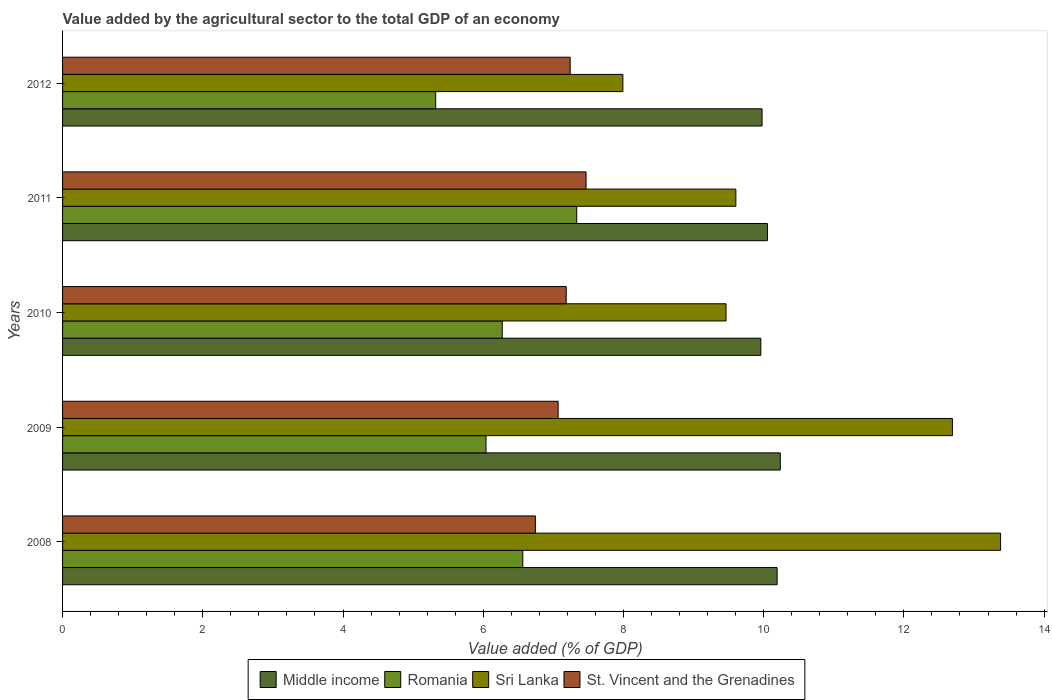How many different coloured bars are there?
Provide a succinct answer. 4. How many groups of bars are there?
Offer a very short reply. 5. Are the number of bars per tick equal to the number of legend labels?
Keep it short and to the point. Yes. How many bars are there on the 1st tick from the top?
Offer a terse response. 4. How many bars are there on the 1st tick from the bottom?
Offer a terse response. 4. What is the label of the 5th group of bars from the top?
Ensure brevity in your answer.  2008. What is the value added by the agricultural sector to the total GDP in Sri Lanka in 2010?
Make the answer very short. 9.46. Across all years, what is the maximum value added by the agricultural sector to the total GDP in Middle income?
Your response must be concise. 10.24. Across all years, what is the minimum value added by the agricultural sector to the total GDP in Sri Lanka?
Keep it short and to the point. 7.99. In which year was the value added by the agricultural sector to the total GDP in Middle income maximum?
Give a very brief answer. 2009. In which year was the value added by the agricultural sector to the total GDP in St. Vincent and the Grenadines minimum?
Give a very brief answer. 2008. What is the total value added by the agricultural sector to the total GDP in Romania in the graph?
Offer a very short reply. 31.53. What is the difference between the value added by the agricultural sector to the total GDP in Middle income in 2008 and that in 2009?
Offer a very short reply. -0.05. What is the difference between the value added by the agricultural sector to the total GDP in Romania in 2010 and the value added by the agricultural sector to the total GDP in Sri Lanka in 2008?
Your answer should be very brief. -7.11. What is the average value added by the agricultural sector to the total GDP in Romania per year?
Provide a short and direct response. 6.31. In the year 2009, what is the difference between the value added by the agricultural sector to the total GDP in Romania and value added by the agricultural sector to the total GDP in St. Vincent and the Grenadines?
Offer a terse response. -1.03. In how many years, is the value added by the agricultural sector to the total GDP in St. Vincent and the Grenadines greater than 13.2 %?
Your answer should be very brief. 0. What is the ratio of the value added by the agricultural sector to the total GDP in St. Vincent and the Grenadines in 2008 to that in 2010?
Ensure brevity in your answer.  0.94. Is the difference between the value added by the agricultural sector to the total GDP in Romania in 2011 and 2012 greater than the difference between the value added by the agricultural sector to the total GDP in St. Vincent and the Grenadines in 2011 and 2012?
Your answer should be very brief. Yes. What is the difference between the highest and the second highest value added by the agricultural sector to the total GDP in Sri Lanka?
Provide a succinct answer. 0.69. What is the difference between the highest and the lowest value added by the agricultural sector to the total GDP in Sri Lanka?
Your response must be concise. 5.39. In how many years, is the value added by the agricultural sector to the total GDP in Romania greater than the average value added by the agricultural sector to the total GDP in Romania taken over all years?
Your answer should be compact. 2. Is the sum of the value added by the agricultural sector to the total GDP in Middle income in 2011 and 2012 greater than the maximum value added by the agricultural sector to the total GDP in St. Vincent and the Grenadines across all years?
Keep it short and to the point. Yes. Is it the case that in every year, the sum of the value added by the agricultural sector to the total GDP in Romania and value added by the agricultural sector to the total GDP in St. Vincent and the Grenadines is greater than the sum of value added by the agricultural sector to the total GDP in Middle income and value added by the agricultural sector to the total GDP in Sri Lanka?
Make the answer very short. No. What does the 2nd bar from the top in 2011 represents?
Ensure brevity in your answer.  Sri Lanka. What does the 2nd bar from the bottom in 2010 represents?
Offer a terse response. Romania. How many bars are there?
Offer a very short reply. 20. Are all the bars in the graph horizontal?
Offer a terse response. Yes. Are the values on the major ticks of X-axis written in scientific E-notation?
Provide a short and direct response. No. Does the graph contain any zero values?
Ensure brevity in your answer.  No. Does the graph contain grids?
Give a very brief answer. No. Where does the legend appear in the graph?
Keep it short and to the point. Bottom center. How are the legend labels stacked?
Offer a very short reply. Horizontal. What is the title of the graph?
Give a very brief answer. Value added by the agricultural sector to the total GDP of an economy. What is the label or title of the X-axis?
Keep it short and to the point. Value added (% of GDP). What is the label or title of the Y-axis?
Provide a short and direct response. Years. What is the Value added (% of GDP) of Middle income in 2008?
Your answer should be compact. 10.19. What is the Value added (% of GDP) in Romania in 2008?
Your answer should be compact. 6.56. What is the Value added (% of GDP) in Sri Lanka in 2008?
Your answer should be very brief. 13.38. What is the Value added (% of GDP) in St. Vincent and the Grenadines in 2008?
Your answer should be compact. 6.74. What is the Value added (% of GDP) in Middle income in 2009?
Your answer should be compact. 10.24. What is the Value added (% of GDP) of Romania in 2009?
Your response must be concise. 6.04. What is the Value added (% of GDP) in Sri Lanka in 2009?
Keep it short and to the point. 12.69. What is the Value added (% of GDP) of St. Vincent and the Grenadines in 2009?
Keep it short and to the point. 7.07. What is the Value added (% of GDP) in Middle income in 2010?
Offer a terse response. 9.96. What is the Value added (% of GDP) of Romania in 2010?
Your answer should be compact. 6.27. What is the Value added (% of GDP) of Sri Lanka in 2010?
Make the answer very short. 9.46. What is the Value added (% of GDP) of St. Vincent and the Grenadines in 2010?
Give a very brief answer. 7.18. What is the Value added (% of GDP) of Middle income in 2011?
Your answer should be very brief. 10.05. What is the Value added (% of GDP) of Romania in 2011?
Ensure brevity in your answer.  7.33. What is the Value added (% of GDP) in Sri Lanka in 2011?
Make the answer very short. 9.6. What is the Value added (% of GDP) in St. Vincent and the Grenadines in 2011?
Keep it short and to the point. 7.47. What is the Value added (% of GDP) of Middle income in 2012?
Offer a terse response. 9.98. What is the Value added (% of GDP) of Romania in 2012?
Give a very brief answer. 5.32. What is the Value added (% of GDP) of Sri Lanka in 2012?
Offer a very short reply. 7.99. What is the Value added (% of GDP) of St. Vincent and the Grenadines in 2012?
Your answer should be compact. 7.24. Across all years, what is the maximum Value added (% of GDP) in Middle income?
Ensure brevity in your answer.  10.24. Across all years, what is the maximum Value added (% of GDP) in Romania?
Keep it short and to the point. 7.33. Across all years, what is the maximum Value added (% of GDP) in Sri Lanka?
Your answer should be very brief. 13.38. Across all years, what is the maximum Value added (% of GDP) of St. Vincent and the Grenadines?
Provide a short and direct response. 7.47. Across all years, what is the minimum Value added (% of GDP) in Middle income?
Your response must be concise. 9.96. Across all years, what is the minimum Value added (% of GDP) of Romania?
Your answer should be compact. 5.32. Across all years, what is the minimum Value added (% of GDP) of Sri Lanka?
Provide a short and direct response. 7.99. Across all years, what is the minimum Value added (% of GDP) in St. Vincent and the Grenadines?
Your answer should be very brief. 6.74. What is the total Value added (% of GDP) in Middle income in the graph?
Give a very brief answer. 50.42. What is the total Value added (% of GDP) of Romania in the graph?
Your response must be concise. 31.53. What is the total Value added (% of GDP) of Sri Lanka in the graph?
Offer a terse response. 53.13. What is the total Value added (% of GDP) of St. Vincent and the Grenadines in the graph?
Provide a succinct answer. 35.7. What is the difference between the Value added (% of GDP) of Middle income in 2008 and that in 2009?
Provide a succinct answer. -0.05. What is the difference between the Value added (% of GDP) in Romania in 2008 and that in 2009?
Offer a very short reply. 0.52. What is the difference between the Value added (% of GDP) in Sri Lanka in 2008 and that in 2009?
Your answer should be very brief. 0.69. What is the difference between the Value added (% of GDP) in St. Vincent and the Grenadines in 2008 and that in 2009?
Your answer should be very brief. -0.32. What is the difference between the Value added (% of GDP) of Middle income in 2008 and that in 2010?
Provide a succinct answer. 0.23. What is the difference between the Value added (% of GDP) in Romania in 2008 and that in 2010?
Provide a succinct answer. 0.29. What is the difference between the Value added (% of GDP) of Sri Lanka in 2008 and that in 2010?
Give a very brief answer. 3.92. What is the difference between the Value added (% of GDP) in St. Vincent and the Grenadines in 2008 and that in 2010?
Your answer should be very brief. -0.44. What is the difference between the Value added (% of GDP) in Middle income in 2008 and that in 2011?
Offer a terse response. 0.14. What is the difference between the Value added (% of GDP) of Romania in 2008 and that in 2011?
Make the answer very short. -0.77. What is the difference between the Value added (% of GDP) of Sri Lanka in 2008 and that in 2011?
Your answer should be compact. 3.78. What is the difference between the Value added (% of GDP) of St. Vincent and the Grenadines in 2008 and that in 2011?
Your answer should be very brief. -0.72. What is the difference between the Value added (% of GDP) of Middle income in 2008 and that in 2012?
Ensure brevity in your answer.  0.21. What is the difference between the Value added (% of GDP) in Romania in 2008 and that in 2012?
Provide a short and direct response. 1.24. What is the difference between the Value added (% of GDP) in Sri Lanka in 2008 and that in 2012?
Your answer should be very brief. 5.39. What is the difference between the Value added (% of GDP) of St. Vincent and the Grenadines in 2008 and that in 2012?
Your answer should be very brief. -0.5. What is the difference between the Value added (% of GDP) in Middle income in 2009 and that in 2010?
Your answer should be very brief. 0.28. What is the difference between the Value added (% of GDP) in Romania in 2009 and that in 2010?
Provide a short and direct response. -0.23. What is the difference between the Value added (% of GDP) of Sri Lanka in 2009 and that in 2010?
Make the answer very short. 3.23. What is the difference between the Value added (% of GDP) of St. Vincent and the Grenadines in 2009 and that in 2010?
Make the answer very short. -0.12. What is the difference between the Value added (% of GDP) of Middle income in 2009 and that in 2011?
Offer a very short reply. 0.18. What is the difference between the Value added (% of GDP) of Romania in 2009 and that in 2011?
Offer a very short reply. -1.29. What is the difference between the Value added (% of GDP) of Sri Lanka in 2009 and that in 2011?
Your response must be concise. 3.09. What is the difference between the Value added (% of GDP) in St. Vincent and the Grenadines in 2009 and that in 2011?
Provide a succinct answer. -0.4. What is the difference between the Value added (% of GDP) of Middle income in 2009 and that in 2012?
Provide a succinct answer. 0.26. What is the difference between the Value added (% of GDP) of Romania in 2009 and that in 2012?
Make the answer very short. 0.72. What is the difference between the Value added (% of GDP) in Sri Lanka in 2009 and that in 2012?
Your response must be concise. 4.7. What is the difference between the Value added (% of GDP) of St. Vincent and the Grenadines in 2009 and that in 2012?
Make the answer very short. -0.17. What is the difference between the Value added (% of GDP) in Middle income in 2010 and that in 2011?
Your answer should be very brief. -0.09. What is the difference between the Value added (% of GDP) in Romania in 2010 and that in 2011?
Keep it short and to the point. -1.06. What is the difference between the Value added (% of GDP) of Sri Lanka in 2010 and that in 2011?
Make the answer very short. -0.14. What is the difference between the Value added (% of GDP) of St. Vincent and the Grenadines in 2010 and that in 2011?
Provide a succinct answer. -0.28. What is the difference between the Value added (% of GDP) in Middle income in 2010 and that in 2012?
Make the answer very short. -0.02. What is the difference between the Value added (% of GDP) of Romania in 2010 and that in 2012?
Your answer should be very brief. 0.95. What is the difference between the Value added (% of GDP) of Sri Lanka in 2010 and that in 2012?
Your answer should be very brief. 1.47. What is the difference between the Value added (% of GDP) in St. Vincent and the Grenadines in 2010 and that in 2012?
Your response must be concise. -0.06. What is the difference between the Value added (% of GDP) of Middle income in 2011 and that in 2012?
Offer a very short reply. 0.08. What is the difference between the Value added (% of GDP) in Romania in 2011 and that in 2012?
Ensure brevity in your answer.  2.01. What is the difference between the Value added (% of GDP) of Sri Lanka in 2011 and that in 2012?
Offer a very short reply. 1.61. What is the difference between the Value added (% of GDP) in St. Vincent and the Grenadines in 2011 and that in 2012?
Your answer should be compact. 0.23. What is the difference between the Value added (% of GDP) of Middle income in 2008 and the Value added (% of GDP) of Romania in 2009?
Your response must be concise. 4.15. What is the difference between the Value added (% of GDP) of Middle income in 2008 and the Value added (% of GDP) of Sri Lanka in 2009?
Your answer should be compact. -2.5. What is the difference between the Value added (% of GDP) in Middle income in 2008 and the Value added (% of GDP) in St. Vincent and the Grenadines in 2009?
Your answer should be very brief. 3.12. What is the difference between the Value added (% of GDP) in Romania in 2008 and the Value added (% of GDP) in Sri Lanka in 2009?
Offer a very short reply. -6.13. What is the difference between the Value added (% of GDP) in Romania in 2008 and the Value added (% of GDP) in St. Vincent and the Grenadines in 2009?
Your answer should be compact. -0.5. What is the difference between the Value added (% of GDP) of Sri Lanka in 2008 and the Value added (% of GDP) of St. Vincent and the Grenadines in 2009?
Provide a short and direct response. 6.31. What is the difference between the Value added (% of GDP) of Middle income in 2008 and the Value added (% of GDP) of Romania in 2010?
Give a very brief answer. 3.92. What is the difference between the Value added (% of GDP) of Middle income in 2008 and the Value added (% of GDP) of Sri Lanka in 2010?
Provide a short and direct response. 0.73. What is the difference between the Value added (% of GDP) of Middle income in 2008 and the Value added (% of GDP) of St. Vincent and the Grenadines in 2010?
Your answer should be compact. 3.01. What is the difference between the Value added (% of GDP) in Romania in 2008 and the Value added (% of GDP) in Sri Lanka in 2010?
Offer a very short reply. -2.9. What is the difference between the Value added (% of GDP) in Romania in 2008 and the Value added (% of GDP) in St. Vincent and the Grenadines in 2010?
Your answer should be compact. -0.62. What is the difference between the Value added (% of GDP) of Sri Lanka in 2008 and the Value added (% of GDP) of St. Vincent and the Grenadines in 2010?
Offer a terse response. 6.2. What is the difference between the Value added (% of GDP) in Middle income in 2008 and the Value added (% of GDP) in Romania in 2011?
Offer a terse response. 2.86. What is the difference between the Value added (% of GDP) in Middle income in 2008 and the Value added (% of GDP) in Sri Lanka in 2011?
Offer a very short reply. 0.59. What is the difference between the Value added (% of GDP) of Middle income in 2008 and the Value added (% of GDP) of St. Vincent and the Grenadines in 2011?
Offer a terse response. 2.72. What is the difference between the Value added (% of GDP) in Romania in 2008 and the Value added (% of GDP) in Sri Lanka in 2011?
Provide a short and direct response. -3.04. What is the difference between the Value added (% of GDP) in Romania in 2008 and the Value added (% of GDP) in St. Vincent and the Grenadines in 2011?
Your response must be concise. -0.9. What is the difference between the Value added (% of GDP) in Sri Lanka in 2008 and the Value added (% of GDP) in St. Vincent and the Grenadines in 2011?
Your answer should be compact. 5.91. What is the difference between the Value added (% of GDP) in Middle income in 2008 and the Value added (% of GDP) in Romania in 2012?
Your answer should be very brief. 4.87. What is the difference between the Value added (% of GDP) of Middle income in 2008 and the Value added (% of GDP) of Sri Lanka in 2012?
Give a very brief answer. 2.2. What is the difference between the Value added (% of GDP) of Middle income in 2008 and the Value added (% of GDP) of St. Vincent and the Grenadines in 2012?
Provide a succinct answer. 2.95. What is the difference between the Value added (% of GDP) in Romania in 2008 and the Value added (% of GDP) in Sri Lanka in 2012?
Your response must be concise. -1.43. What is the difference between the Value added (% of GDP) in Romania in 2008 and the Value added (% of GDP) in St. Vincent and the Grenadines in 2012?
Provide a short and direct response. -0.68. What is the difference between the Value added (% of GDP) of Sri Lanka in 2008 and the Value added (% of GDP) of St. Vincent and the Grenadines in 2012?
Provide a succinct answer. 6.14. What is the difference between the Value added (% of GDP) of Middle income in 2009 and the Value added (% of GDP) of Romania in 2010?
Your response must be concise. 3.97. What is the difference between the Value added (% of GDP) of Middle income in 2009 and the Value added (% of GDP) of Sri Lanka in 2010?
Keep it short and to the point. 0.77. What is the difference between the Value added (% of GDP) in Middle income in 2009 and the Value added (% of GDP) in St. Vincent and the Grenadines in 2010?
Provide a short and direct response. 3.05. What is the difference between the Value added (% of GDP) in Romania in 2009 and the Value added (% of GDP) in Sri Lanka in 2010?
Provide a succinct answer. -3.42. What is the difference between the Value added (% of GDP) of Romania in 2009 and the Value added (% of GDP) of St. Vincent and the Grenadines in 2010?
Provide a short and direct response. -1.14. What is the difference between the Value added (% of GDP) of Sri Lanka in 2009 and the Value added (% of GDP) of St. Vincent and the Grenadines in 2010?
Offer a terse response. 5.51. What is the difference between the Value added (% of GDP) in Middle income in 2009 and the Value added (% of GDP) in Romania in 2011?
Your answer should be very brief. 2.9. What is the difference between the Value added (% of GDP) in Middle income in 2009 and the Value added (% of GDP) in Sri Lanka in 2011?
Offer a terse response. 0.63. What is the difference between the Value added (% of GDP) of Middle income in 2009 and the Value added (% of GDP) of St. Vincent and the Grenadines in 2011?
Your answer should be very brief. 2.77. What is the difference between the Value added (% of GDP) of Romania in 2009 and the Value added (% of GDP) of Sri Lanka in 2011?
Ensure brevity in your answer.  -3.56. What is the difference between the Value added (% of GDP) of Romania in 2009 and the Value added (% of GDP) of St. Vincent and the Grenadines in 2011?
Make the answer very short. -1.43. What is the difference between the Value added (% of GDP) of Sri Lanka in 2009 and the Value added (% of GDP) of St. Vincent and the Grenadines in 2011?
Ensure brevity in your answer.  5.23. What is the difference between the Value added (% of GDP) in Middle income in 2009 and the Value added (% of GDP) in Romania in 2012?
Offer a very short reply. 4.92. What is the difference between the Value added (% of GDP) in Middle income in 2009 and the Value added (% of GDP) in Sri Lanka in 2012?
Provide a short and direct response. 2.24. What is the difference between the Value added (% of GDP) of Middle income in 2009 and the Value added (% of GDP) of St. Vincent and the Grenadines in 2012?
Provide a succinct answer. 3. What is the difference between the Value added (% of GDP) in Romania in 2009 and the Value added (% of GDP) in Sri Lanka in 2012?
Your response must be concise. -1.95. What is the difference between the Value added (% of GDP) of Romania in 2009 and the Value added (% of GDP) of St. Vincent and the Grenadines in 2012?
Give a very brief answer. -1.2. What is the difference between the Value added (% of GDP) in Sri Lanka in 2009 and the Value added (% of GDP) in St. Vincent and the Grenadines in 2012?
Ensure brevity in your answer.  5.45. What is the difference between the Value added (% of GDP) in Middle income in 2010 and the Value added (% of GDP) in Romania in 2011?
Provide a succinct answer. 2.63. What is the difference between the Value added (% of GDP) of Middle income in 2010 and the Value added (% of GDP) of Sri Lanka in 2011?
Offer a very short reply. 0.36. What is the difference between the Value added (% of GDP) of Middle income in 2010 and the Value added (% of GDP) of St. Vincent and the Grenadines in 2011?
Your response must be concise. 2.49. What is the difference between the Value added (% of GDP) of Romania in 2010 and the Value added (% of GDP) of Sri Lanka in 2011?
Provide a succinct answer. -3.33. What is the difference between the Value added (% of GDP) of Romania in 2010 and the Value added (% of GDP) of St. Vincent and the Grenadines in 2011?
Make the answer very short. -1.2. What is the difference between the Value added (% of GDP) of Sri Lanka in 2010 and the Value added (% of GDP) of St. Vincent and the Grenadines in 2011?
Your answer should be compact. 2. What is the difference between the Value added (% of GDP) in Middle income in 2010 and the Value added (% of GDP) in Romania in 2012?
Make the answer very short. 4.64. What is the difference between the Value added (% of GDP) in Middle income in 2010 and the Value added (% of GDP) in Sri Lanka in 2012?
Make the answer very short. 1.97. What is the difference between the Value added (% of GDP) in Middle income in 2010 and the Value added (% of GDP) in St. Vincent and the Grenadines in 2012?
Ensure brevity in your answer.  2.72. What is the difference between the Value added (% of GDP) of Romania in 2010 and the Value added (% of GDP) of Sri Lanka in 2012?
Your answer should be very brief. -1.72. What is the difference between the Value added (% of GDP) in Romania in 2010 and the Value added (% of GDP) in St. Vincent and the Grenadines in 2012?
Your response must be concise. -0.97. What is the difference between the Value added (% of GDP) in Sri Lanka in 2010 and the Value added (% of GDP) in St. Vincent and the Grenadines in 2012?
Ensure brevity in your answer.  2.22. What is the difference between the Value added (% of GDP) of Middle income in 2011 and the Value added (% of GDP) of Romania in 2012?
Your answer should be very brief. 4.73. What is the difference between the Value added (% of GDP) of Middle income in 2011 and the Value added (% of GDP) of Sri Lanka in 2012?
Your response must be concise. 2.06. What is the difference between the Value added (% of GDP) of Middle income in 2011 and the Value added (% of GDP) of St. Vincent and the Grenadines in 2012?
Make the answer very short. 2.81. What is the difference between the Value added (% of GDP) in Romania in 2011 and the Value added (% of GDP) in Sri Lanka in 2012?
Give a very brief answer. -0.66. What is the difference between the Value added (% of GDP) of Romania in 2011 and the Value added (% of GDP) of St. Vincent and the Grenadines in 2012?
Ensure brevity in your answer.  0.09. What is the difference between the Value added (% of GDP) in Sri Lanka in 2011 and the Value added (% of GDP) in St. Vincent and the Grenadines in 2012?
Your response must be concise. 2.36. What is the average Value added (% of GDP) in Middle income per year?
Offer a terse response. 10.08. What is the average Value added (% of GDP) in Romania per year?
Provide a succinct answer. 6.31. What is the average Value added (% of GDP) of Sri Lanka per year?
Your answer should be very brief. 10.63. What is the average Value added (% of GDP) in St. Vincent and the Grenadines per year?
Your answer should be very brief. 7.14. In the year 2008, what is the difference between the Value added (% of GDP) in Middle income and Value added (% of GDP) in Romania?
Provide a short and direct response. 3.63. In the year 2008, what is the difference between the Value added (% of GDP) in Middle income and Value added (% of GDP) in Sri Lanka?
Your answer should be compact. -3.19. In the year 2008, what is the difference between the Value added (% of GDP) of Middle income and Value added (% of GDP) of St. Vincent and the Grenadines?
Ensure brevity in your answer.  3.45. In the year 2008, what is the difference between the Value added (% of GDP) in Romania and Value added (% of GDP) in Sri Lanka?
Your answer should be very brief. -6.82. In the year 2008, what is the difference between the Value added (% of GDP) in Romania and Value added (% of GDP) in St. Vincent and the Grenadines?
Give a very brief answer. -0.18. In the year 2008, what is the difference between the Value added (% of GDP) in Sri Lanka and Value added (% of GDP) in St. Vincent and the Grenadines?
Ensure brevity in your answer.  6.64. In the year 2009, what is the difference between the Value added (% of GDP) of Middle income and Value added (% of GDP) of Romania?
Provide a short and direct response. 4.2. In the year 2009, what is the difference between the Value added (% of GDP) in Middle income and Value added (% of GDP) in Sri Lanka?
Your answer should be very brief. -2.46. In the year 2009, what is the difference between the Value added (% of GDP) in Middle income and Value added (% of GDP) in St. Vincent and the Grenadines?
Keep it short and to the point. 3.17. In the year 2009, what is the difference between the Value added (% of GDP) in Romania and Value added (% of GDP) in Sri Lanka?
Your answer should be very brief. -6.65. In the year 2009, what is the difference between the Value added (% of GDP) of Romania and Value added (% of GDP) of St. Vincent and the Grenadines?
Give a very brief answer. -1.03. In the year 2009, what is the difference between the Value added (% of GDP) in Sri Lanka and Value added (% of GDP) in St. Vincent and the Grenadines?
Your answer should be compact. 5.62. In the year 2010, what is the difference between the Value added (% of GDP) in Middle income and Value added (% of GDP) in Romania?
Offer a terse response. 3.69. In the year 2010, what is the difference between the Value added (% of GDP) in Middle income and Value added (% of GDP) in Sri Lanka?
Offer a terse response. 0.5. In the year 2010, what is the difference between the Value added (% of GDP) in Middle income and Value added (% of GDP) in St. Vincent and the Grenadines?
Keep it short and to the point. 2.78. In the year 2010, what is the difference between the Value added (% of GDP) in Romania and Value added (% of GDP) in Sri Lanka?
Provide a short and direct response. -3.19. In the year 2010, what is the difference between the Value added (% of GDP) of Romania and Value added (% of GDP) of St. Vincent and the Grenadines?
Your answer should be very brief. -0.91. In the year 2010, what is the difference between the Value added (% of GDP) in Sri Lanka and Value added (% of GDP) in St. Vincent and the Grenadines?
Offer a very short reply. 2.28. In the year 2011, what is the difference between the Value added (% of GDP) in Middle income and Value added (% of GDP) in Romania?
Give a very brief answer. 2.72. In the year 2011, what is the difference between the Value added (% of GDP) in Middle income and Value added (% of GDP) in Sri Lanka?
Your answer should be compact. 0.45. In the year 2011, what is the difference between the Value added (% of GDP) of Middle income and Value added (% of GDP) of St. Vincent and the Grenadines?
Offer a very short reply. 2.59. In the year 2011, what is the difference between the Value added (% of GDP) in Romania and Value added (% of GDP) in Sri Lanka?
Your answer should be compact. -2.27. In the year 2011, what is the difference between the Value added (% of GDP) of Romania and Value added (% of GDP) of St. Vincent and the Grenadines?
Your response must be concise. -0.13. In the year 2011, what is the difference between the Value added (% of GDP) of Sri Lanka and Value added (% of GDP) of St. Vincent and the Grenadines?
Ensure brevity in your answer.  2.14. In the year 2012, what is the difference between the Value added (% of GDP) of Middle income and Value added (% of GDP) of Romania?
Provide a short and direct response. 4.66. In the year 2012, what is the difference between the Value added (% of GDP) in Middle income and Value added (% of GDP) in Sri Lanka?
Keep it short and to the point. 1.99. In the year 2012, what is the difference between the Value added (% of GDP) in Middle income and Value added (% of GDP) in St. Vincent and the Grenadines?
Keep it short and to the point. 2.74. In the year 2012, what is the difference between the Value added (% of GDP) in Romania and Value added (% of GDP) in Sri Lanka?
Provide a short and direct response. -2.67. In the year 2012, what is the difference between the Value added (% of GDP) of Romania and Value added (% of GDP) of St. Vincent and the Grenadines?
Make the answer very short. -1.92. In the year 2012, what is the difference between the Value added (% of GDP) in Sri Lanka and Value added (% of GDP) in St. Vincent and the Grenadines?
Your answer should be very brief. 0.75. What is the ratio of the Value added (% of GDP) in Middle income in 2008 to that in 2009?
Make the answer very short. 1. What is the ratio of the Value added (% of GDP) of Romania in 2008 to that in 2009?
Make the answer very short. 1.09. What is the ratio of the Value added (% of GDP) in Sri Lanka in 2008 to that in 2009?
Provide a short and direct response. 1.05. What is the ratio of the Value added (% of GDP) in St. Vincent and the Grenadines in 2008 to that in 2009?
Make the answer very short. 0.95. What is the ratio of the Value added (% of GDP) of Middle income in 2008 to that in 2010?
Keep it short and to the point. 1.02. What is the ratio of the Value added (% of GDP) in Romania in 2008 to that in 2010?
Your answer should be very brief. 1.05. What is the ratio of the Value added (% of GDP) of Sri Lanka in 2008 to that in 2010?
Provide a short and direct response. 1.41. What is the ratio of the Value added (% of GDP) of St. Vincent and the Grenadines in 2008 to that in 2010?
Ensure brevity in your answer.  0.94. What is the ratio of the Value added (% of GDP) of Middle income in 2008 to that in 2011?
Offer a very short reply. 1.01. What is the ratio of the Value added (% of GDP) in Romania in 2008 to that in 2011?
Provide a short and direct response. 0.9. What is the ratio of the Value added (% of GDP) of Sri Lanka in 2008 to that in 2011?
Make the answer very short. 1.39. What is the ratio of the Value added (% of GDP) of St. Vincent and the Grenadines in 2008 to that in 2011?
Make the answer very short. 0.9. What is the ratio of the Value added (% of GDP) in Middle income in 2008 to that in 2012?
Make the answer very short. 1.02. What is the ratio of the Value added (% of GDP) of Romania in 2008 to that in 2012?
Give a very brief answer. 1.23. What is the ratio of the Value added (% of GDP) of Sri Lanka in 2008 to that in 2012?
Offer a terse response. 1.67. What is the ratio of the Value added (% of GDP) in St. Vincent and the Grenadines in 2008 to that in 2012?
Your answer should be compact. 0.93. What is the ratio of the Value added (% of GDP) of Middle income in 2009 to that in 2010?
Provide a succinct answer. 1.03. What is the ratio of the Value added (% of GDP) of Romania in 2009 to that in 2010?
Ensure brevity in your answer.  0.96. What is the ratio of the Value added (% of GDP) of Sri Lanka in 2009 to that in 2010?
Your answer should be compact. 1.34. What is the ratio of the Value added (% of GDP) of St. Vincent and the Grenadines in 2009 to that in 2010?
Your answer should be compact. 0.98. What is the ratio of the Value added (% of GDP) of Middle income in 2009 to that in 2011?
Make the answer very short. 1.02. What is the ratio of the Value added (% of GDP) of Romania in 2009 to that in 2011?
Your answer should be very brief. 0.82. What is the ratio of the Value added (% of GDP) of Sri Lanka in 2009 to that in 2011?
Your answer should be very brief. 1.32. What is the ratio of the Value added (% of GDP) of St. Vincent and the Grenadines in 2009 to that in 2011?
Keep it short and to the point. 0.95. What is the ratio of the Value added (% of GDP) of Middle income in 2009 to that in 2012?
Provide a succinct answer. 1.03. What is the ratio of the Value added (% of GDP) of Romania in 2009 to that in 2012?
Make the answer very short. 1.13. What is the ratio of the Value added (% of GDP) in Sri Lanka in 2009 to that in 2012?
Your answer should be very brief. 1.59. What is the ratio of the Value added (% of GDP) of St. Vincent and the Grenadines in 2009 to that in 2012?
Your response must be concise. 0.98. What is the ratio of the Value added (% of GDP) in Middle income in 2010 to that in 2011?
Offer a terse response. 0.99. What is the ratio of the Value added (% of GDP) in Romania in 2010 to that in 2011?
Your response must be concise. 0.86. What is the ratio of the Value added (% of GDP) in Sri Lanka in 2010 to that in 2011?
Keep it short and to the point. 0.99. What is the ratio of the Value added (% of GDP) of St. Vincent and the Grenadines in 2010 to that in 2011?
Your answer should be very brief. 0.96. What is the ratio of the Value added (% of GDP) in Middle income in 2010 to that in 2012?
Offer a very short reply. 1. What is the ratio of the Value added (% of GDP) of Romania in 2010 to that in 2012?
Your answer should be compact. 1.18. What is the ratio of the Value added (% of GDP) in Sri Lanka in 2010 to that in 2012?
Your answer should be very brief. 1.18. What is the ratio of the Value added (% of GDP) of Middle income in 2011 to that in 2012?
Offer a terse response. 1.01. What is the ratio of the Value added (% of GDP) of Romania in 2011 to that in 2012?
Offer a very short reply. 1.38. What is the ratio of the Value added (% of GDP) in Sri Lanka in 2011 to that in 2012?
Provide a succinct answer. 1.2. What is the ratio of the Value added (% of GDP) in St. Vincent and the Grenadines in 2011 to that in 2012?
Keep it short and to the point. 1.03. What is the difference between the highest and the second highest Value added (% of GDP) of Middle income?
Make the answer very short. 0.05. What is the difference between the highest and the second highest Value added (% of GDP) of Romania?
Keep it short and to the point. 0.77. What is the difference between the highest and the second highest Value added (% of GDP) of Sri Lanka?
Keep it short and to the point. 0.69. What is the difference between the highest and the second highest Value added (% of GDP) of St. Vincent and the Grenadines?
Offer a very short reply. 0.23. What is the difference between the highest and the lowest Value added (% of GDP) of Middle income?
Offer a very short reply. 0.28. What is the difference between the highest and the lowest Value added (% of GDP) in Romania?
Make the answer very short. 2.01. What is the difference between the highest and the lowest Value added (% of GDP) of Sri Lanka?
Ensure brevity in your answer.  5.39. What is the difference between the highest and the lowest Value added (% of GDP) in St. Vincent and the Grenadines?
Provide a short and direct response. 0.72. 